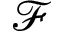Convert formula to latex. <formula><loc_0><loc_0><loc_500><loc_500>\mathcal { F }</formula> 